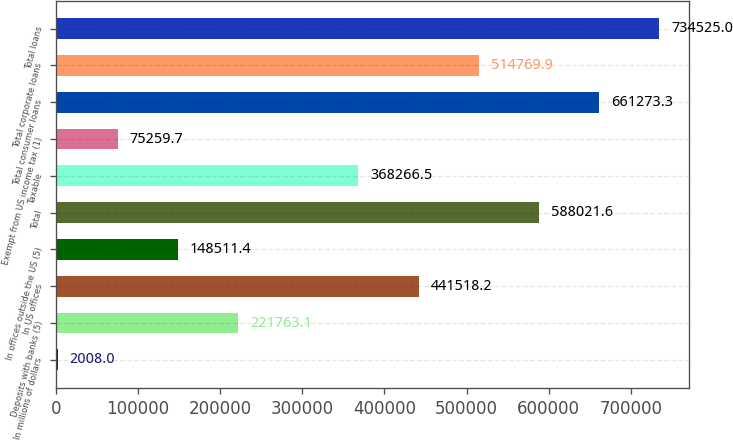Convert chart. <chart><loc_0><loc_0><loc_500><loc_500><bar_chart><fcel>In millions of dollars<fcel>Deposits with banks (5)<fcel>In US offices<fcel>In offices outside the US (5)<fcel>Total<fcel>Taxable<fcel>Exempt from US income tax (1)<fcel>Total consumer loans<fcel>Total corporate loans<fcel>Total loans<nl><fcel>2008<fcel>221763<fcel>441518<fcel>148511<fcel>588022<fcel>368266<fcel>75259.7<fcel>661273<fcel>514770<fcel>734525<nl></chart> 